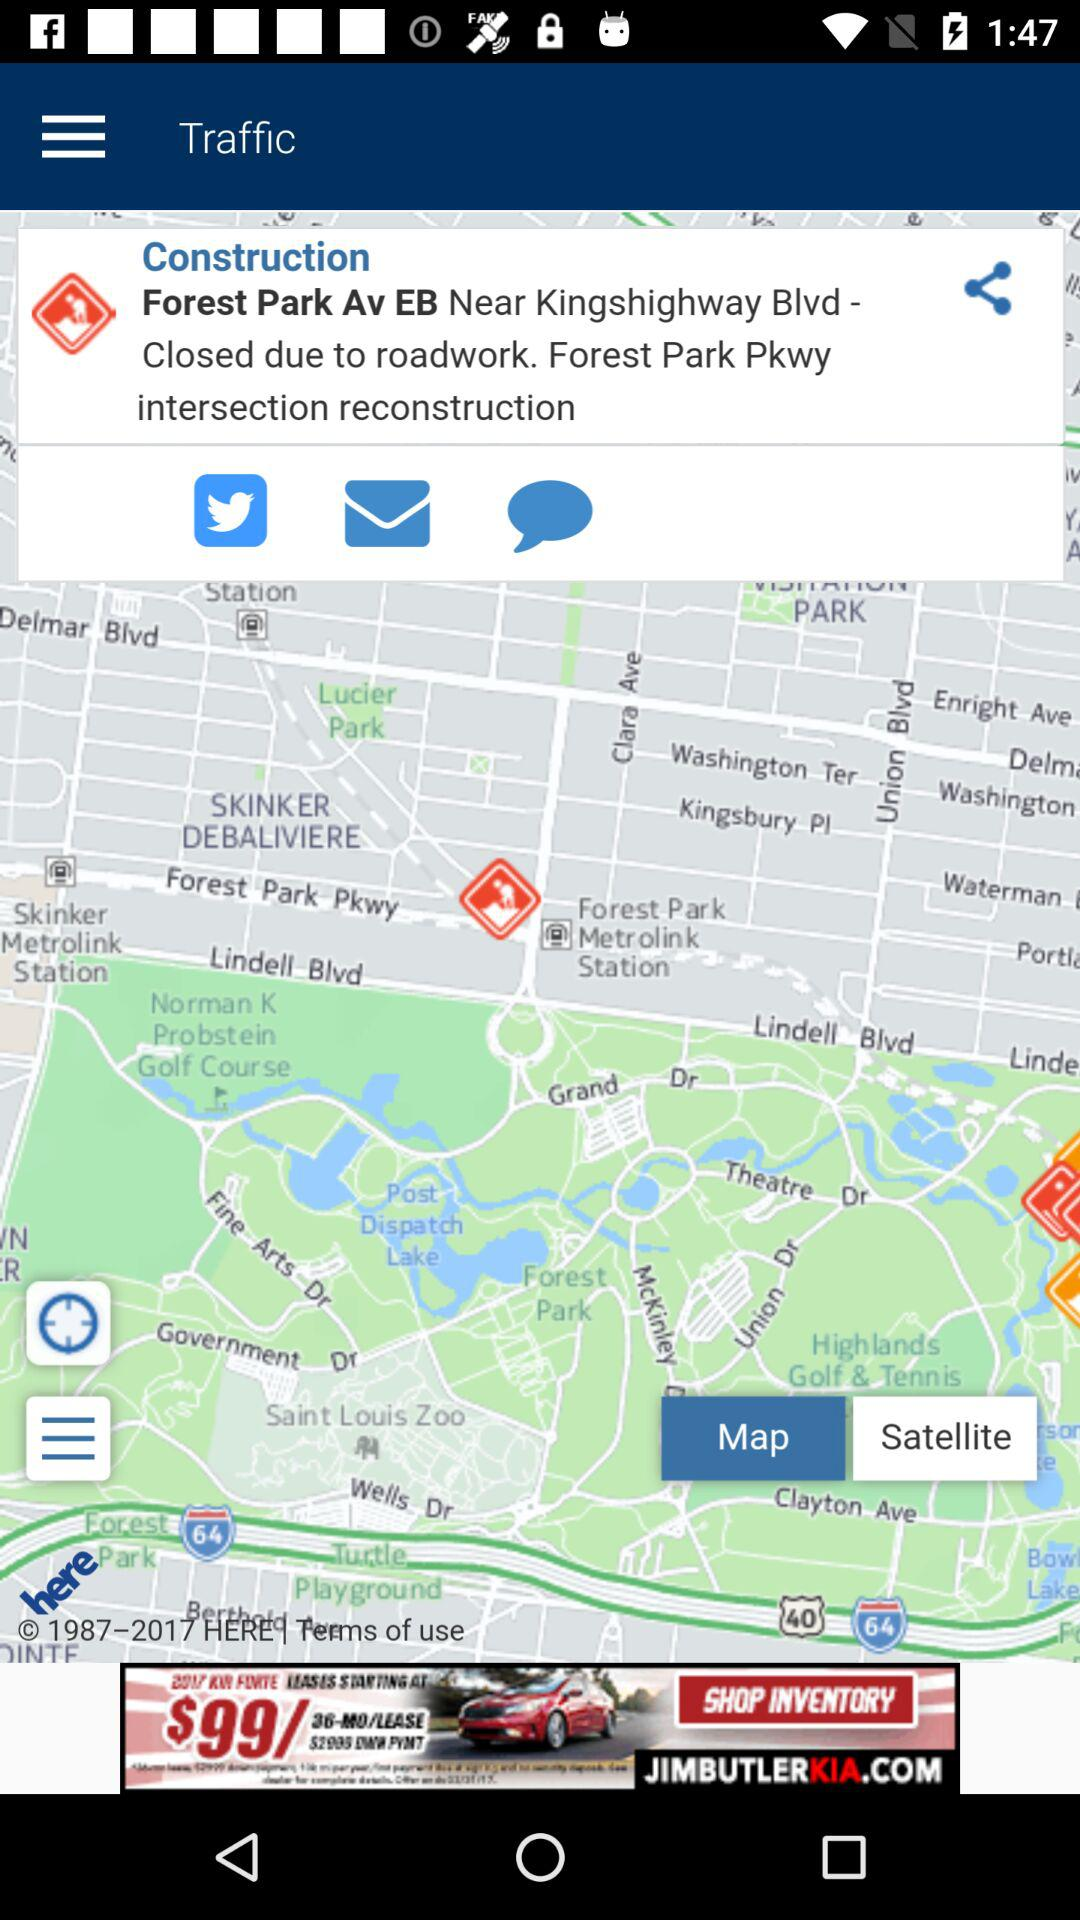How much is the price of the car advertised on the map?
Answer the question using a single word or phrase. $99/mo 